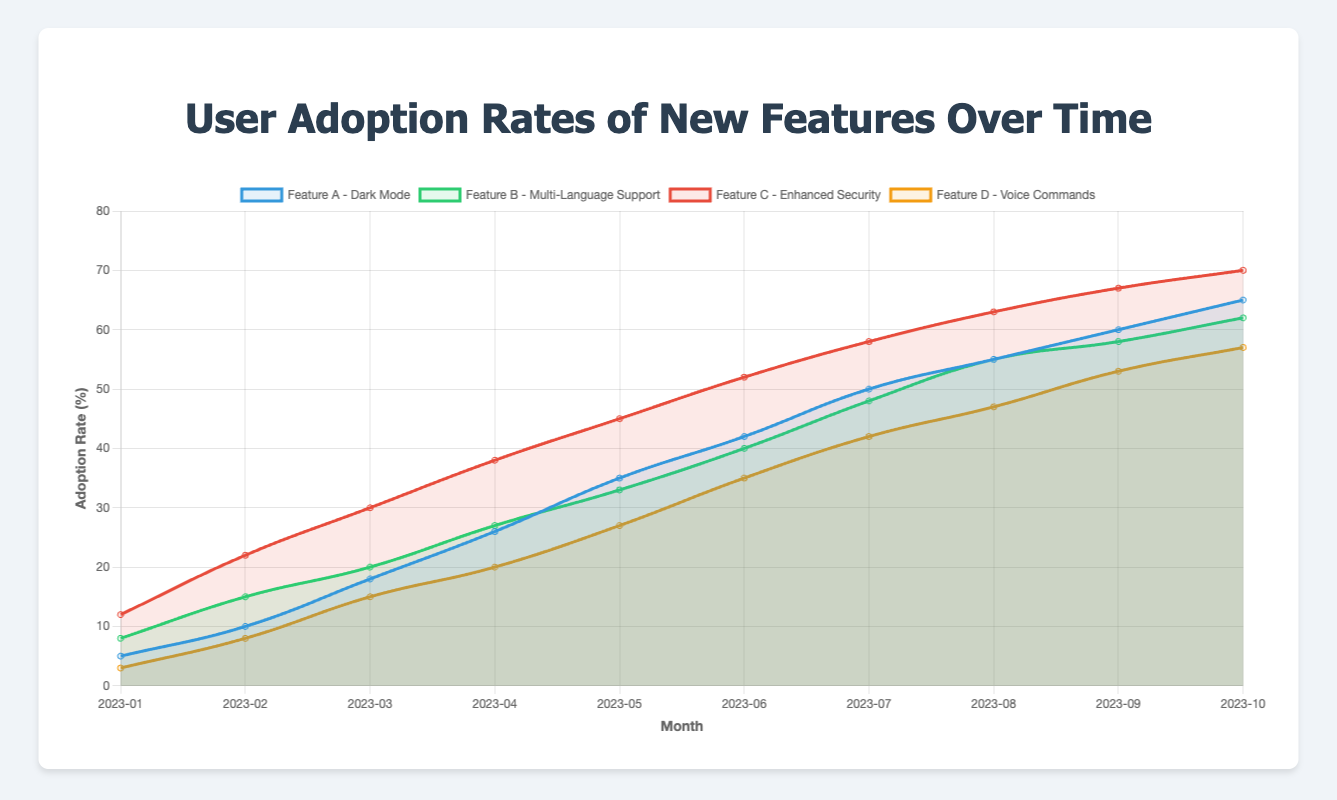What is the highest adoption rate for Feature C - Enhanced Security? To find the highest adoption rate for Feature C, look at the data for the entire time period from January 2023 to October 2023. The highest adoption rate is 70% in October 2023.
Answer: 70% Which feature had the highest adoption rate in January 2023? Compare the adoption rates of all features in January 2023. Feature C - Enhanced Security had the highest rate of 12%.
Answer: Feature C - Enhanced Security Between February and March 2023, which feature experienced the largest increase in adoption rate? Calculate the increase for each feature between February and March. Feature A increased by 8%, Feature B by 5%, Feature C by 8%, and Feature D by 7%. Feature A and Feature C tie for the largest increase of 8%.
Answer: Feature A - Dark Mode and Feature C - Enhanced Security What is the difference in adoption rate between Feature A and Feature D in October 2023? Compare the adoption rates for Feature A and Feature D in October 2023. Feature A is 65% and Feature D is 57%. The difference is 65% - 57% = 8%.
Answer: 8% What is the average adoption rate of Feature B over the entire period? Sum all the monthly adoption rates for Feature B (8 + 15 + 20 + 27 + 33 + 40 + 48 + 55 + 58 + 62 = 366) and divide by the number of months (10). The average is 366 / 10 = 36.6%.
Answer: 36.6% By how much did the adoption rate of Feature D increase from April to October 2023? Find adoption rates for Feature D in April and October 2023, which are 20% and 57% respectively. The increase is 57% - 20% = 37%.
Answer: 37% Which feature had the closest adoption rates in June and July 2023? Compare the adoption rates of each feature in June and July 2023. Feature D had rates of 35% and 42%, showing a difference of 7%. This is the smallest difference.
Answer: Feature D - Voice Commands What is the trend for Feature B from July to October 2023? Observe the adoption rates of Feature B from July to October 2023: 48%, 55%, 58%, and 62%. There is a consistent upward trend in adoption rates.
Answer: Upward trend 